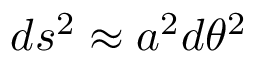Convert formula to latex. <formula><loc_0><loc_0><loc_500><loc_500>d s ^ { 2 } \approx a ^ { 2 } d \theta ^ { 2 }</formula> 